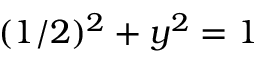<formula> <loc_0><loc_0><loc_500><loc_500>( 1 / 2 ) ^ { 2 } + y ^ { 2 } = 1</formula> 